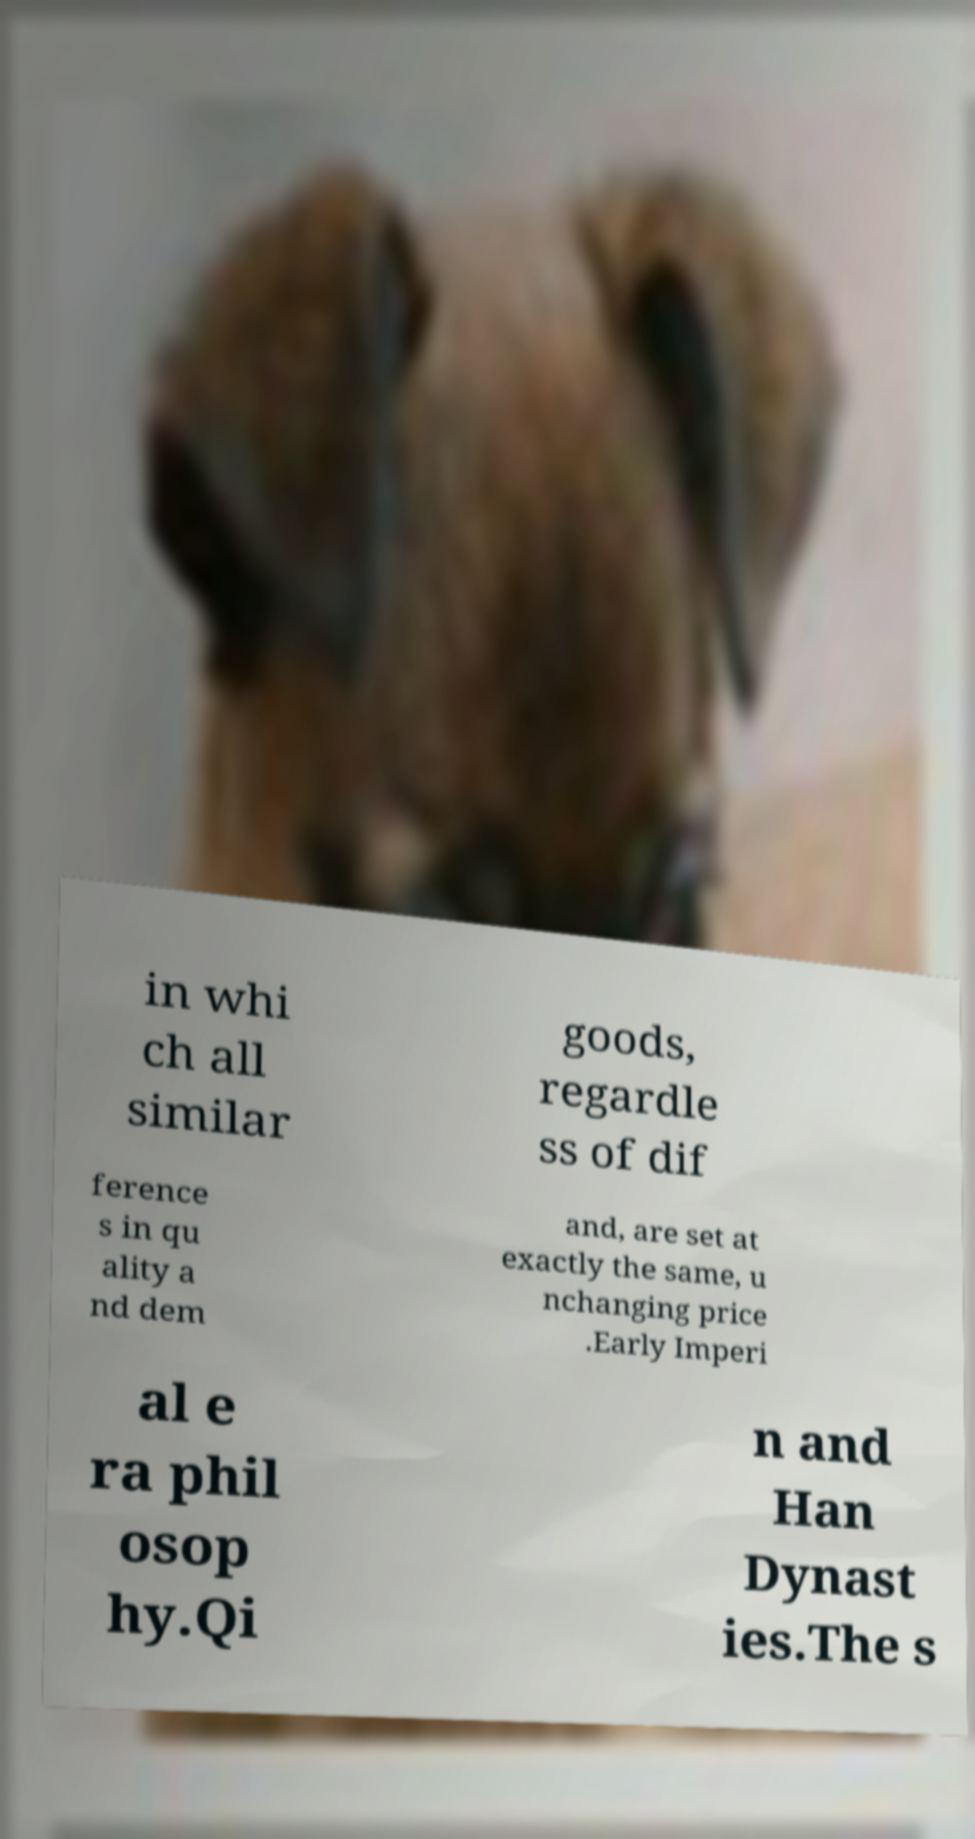Please identify and transcribe the text found in this image. in whi ch all similar goods, regardle ss of dif ference s in qu ality a nd dem and, are set at exactly the same, u nchanging price .Early Imperi al e ra phil osop hy.Qi n and Han Dynast ies.The s 